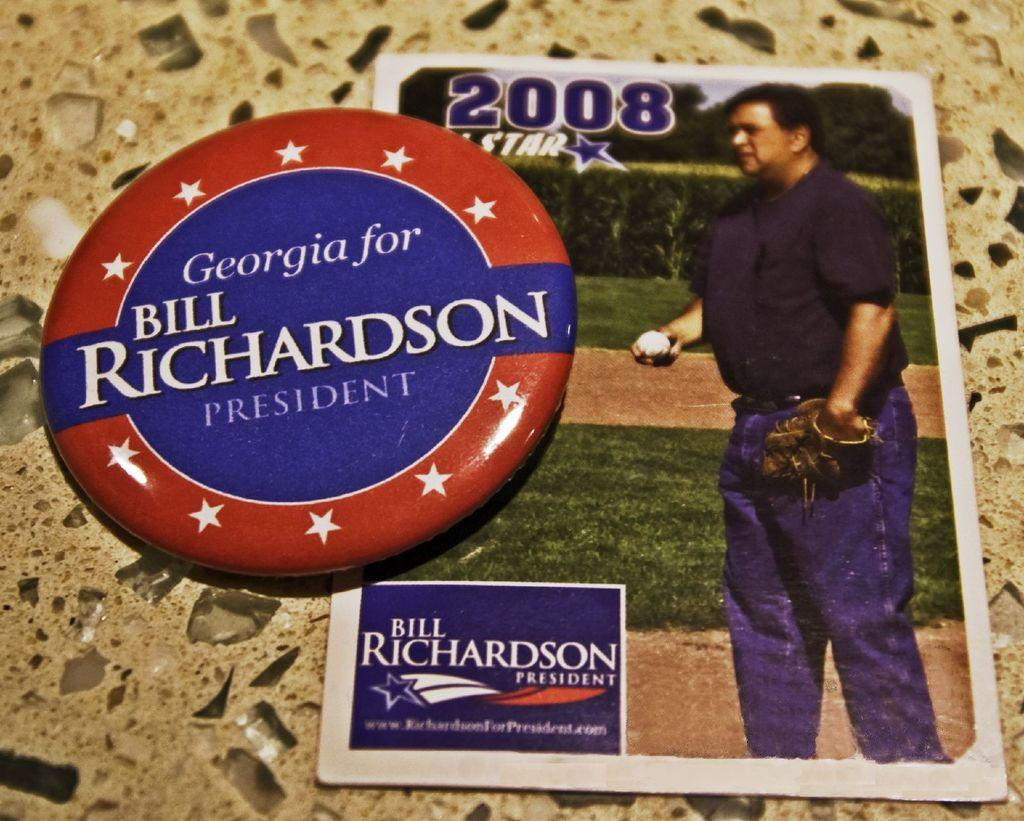What is the main subject in the center of the image? There is a badge in the center of the image. Can you describe any other objects in the image? There is a card on the floor. What type of industry is depicted in the image? There is no industry depicted in the image; it only features a badge and a card on the floor. Can you see any bones in the image? There are no bones present in the image. 